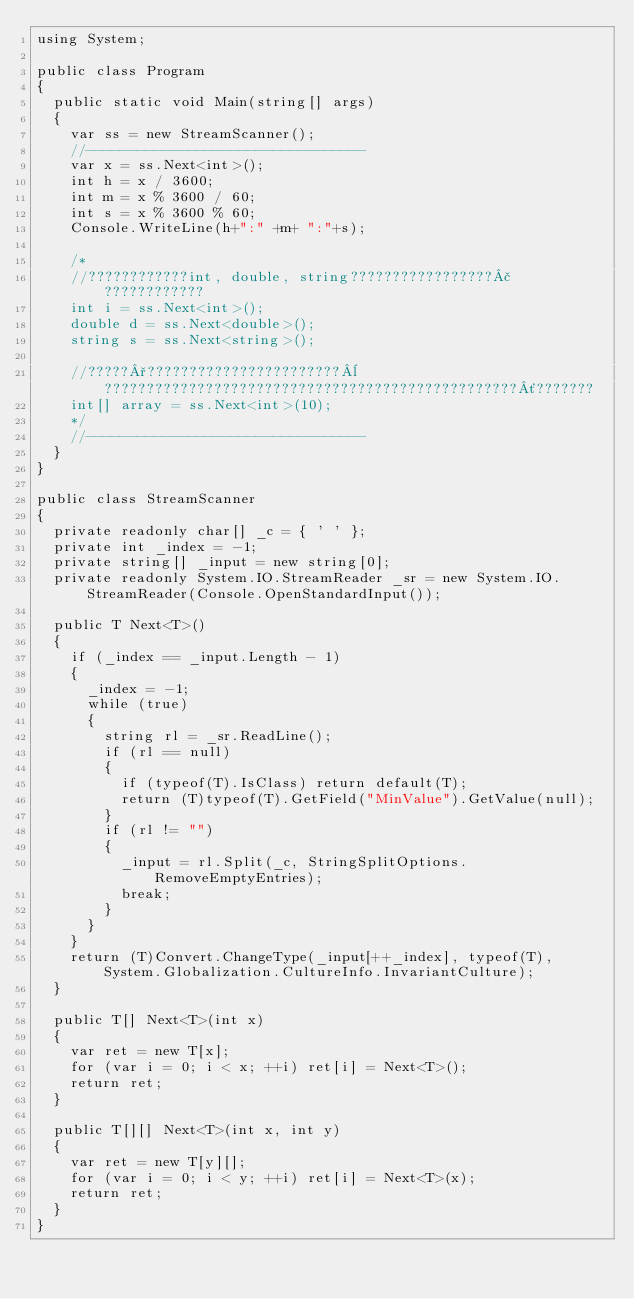Convert code to text. <code><loc_0><loc_0><loc_500><loc_500><_C#_>using System;

public class Program
{
	public static void Main(string[] args)
	{
		var ss = new StreamScanner();
		//---------------------------------
		var x = ss.Next<int>();
		int h = x / 3600;
		int m = x % 3600 / 60;
		int s = x % 3600 % 60;
		Console.WriteLine(h+":" +m+ ":"+s);

		/*
		//????????????int, double, string?????????????????£????????????
		int i = ss.Next<int>();
		double d = ss.Next<double>();
		string s = ss.Next<string>();

		//?????°???????????????????????¨?????????????????????????????????????????????????´???????
		int[] array = ss.Next<int>(10);
		*/
		//---------------------------------
	}
}

public class StreamScanner
{
	private readonly char[] _c = { ' ' };
	private int _index = -1;
	private string[] _input = new string[0];
	private readonly System.IO.StreamReader _sr = new System.IO.StreamReader(Console.OpenStandardInput());

	public T Next<T>()
	{
		if (_index == _input.Length - 1)
		{
			_index = -1;
			while (true)
			{
				string rl = _sr.ReadLine();
				if (rl == null)
				{
					if (typeof(T).IsClass) return default(T);
					return (T)typeof(T).GetField("MinValue").GetValue(null);
				}
				if (rl != "")
				{
					_input = rl.Split(_c, StringSplitOptions.RemoveEmptyEntries);
					break;
				}
			}
		}
		return (T)Convert.ChangeType(_input[++_index], typeof(T), System.Globalization.CultureInfo.InvariantCulture);
	}

	public T[] Next<T>(int x)
	{
		var ret = new T[x];
		for (var i = 0; i < x; ++i) ret[i] = Next<T>();
		return ret;
	}

	public T[][] Next<T>(int x, int y)
	{
		var ret = new T[y][];
		for (var i = 0; i < y; ++i) ret[i] = Next<T>(x);
		return ret;
	}
}</code> 